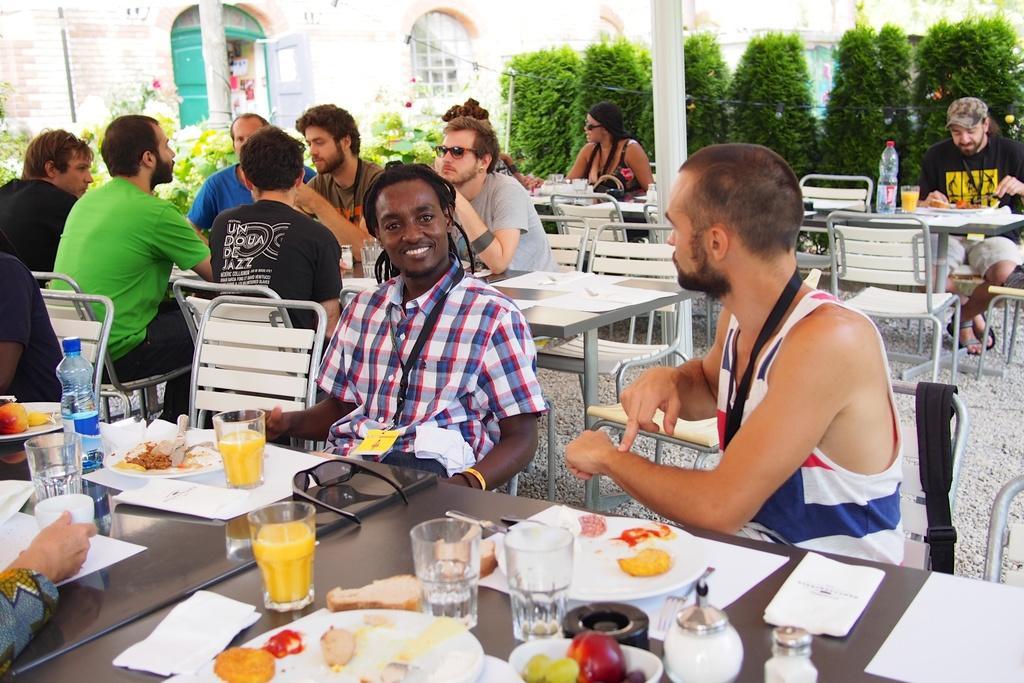How would you summarize this image in a sentence or two? This is a picture taken in the outdoors. There are a group of people sitting on chairs in front of these people there is a table on the table there are glasses, plates, goggle, bottle, fruits and some food items. Behind the people there is a pole, plants and a building. 